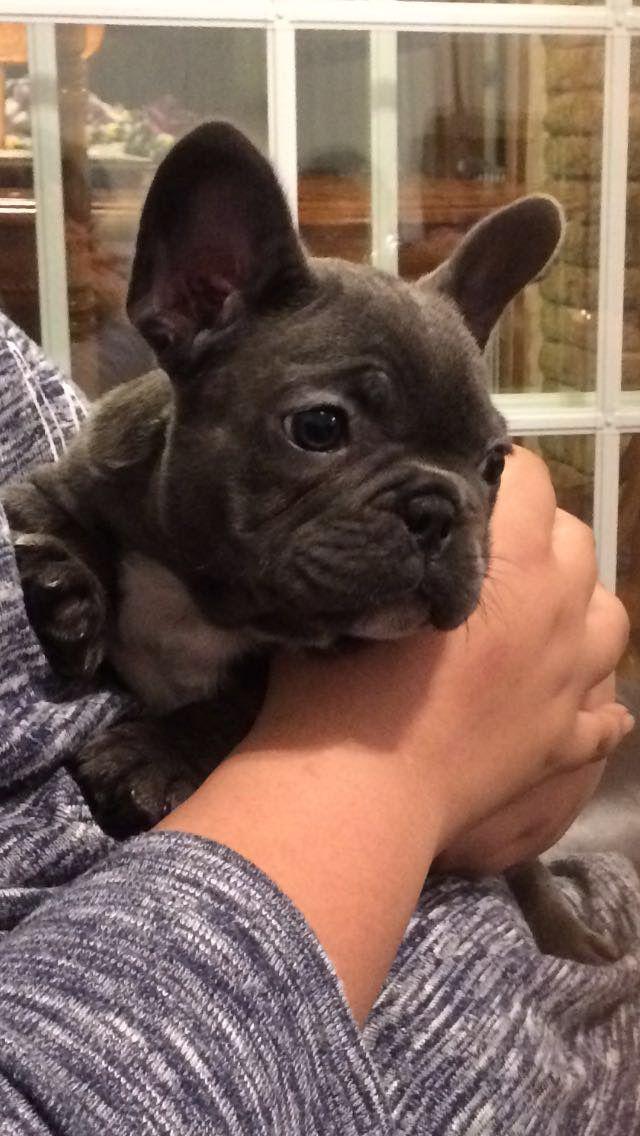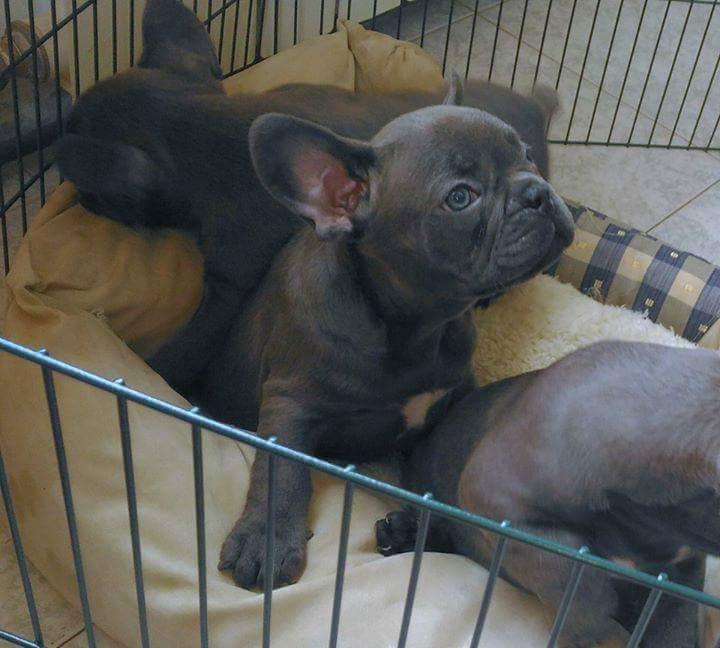The first image is the image on the left, the second image is the image on the right. For the images shown, is this caption "There is only one puppy in the picture on the left." true? Answer yes or no. Yes. 